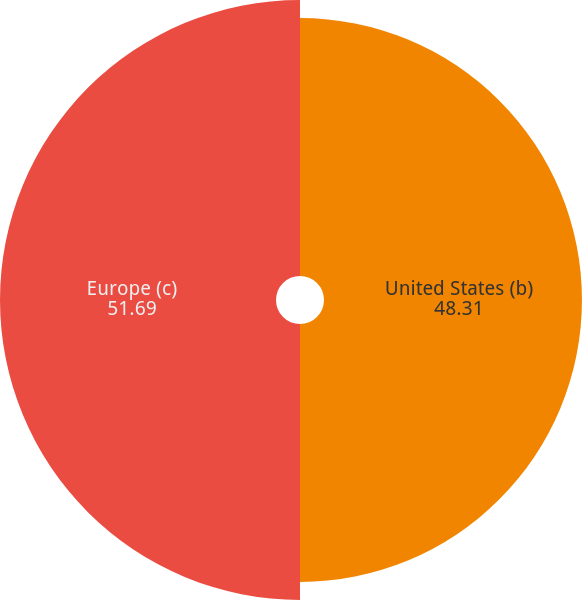Convert chart. <chart><loc_0><loc_0><loc_500><loc_500><pie_chart><fcel>United States (b)<fcel>Europe (c)<nl><fcel>48.31%<fcel>51.69%<nl></chart> 